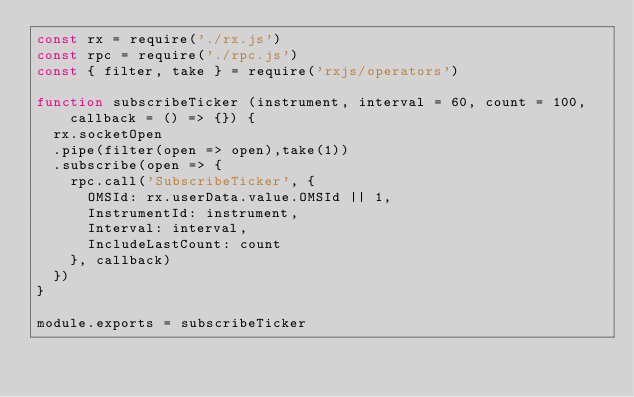Convert code to text. <code><loc_0><loc_0><loc_500><loc_500><_JavaScript_>const rx = require('./rx.js')
const rpc = require('./rpc.js')
const { filter, take } = require('rxjs/operators')

function subscribeTicker (instrument, interval = 60, count = 100, callback = () => {}) {
  rx.socketOpen
  .pipe(filter(open => open),take(1))
  .subscribe(open => {
    rpc.call('SubscribeTicker', {
      OMSId: rx.userData.value.OMSId || 1,
      InstrumentId: instrument,
      Interval: interval,
      IncludeLastCount: count
    }, callback)
  })
}

module.exports = subscribeTicker
</code> 